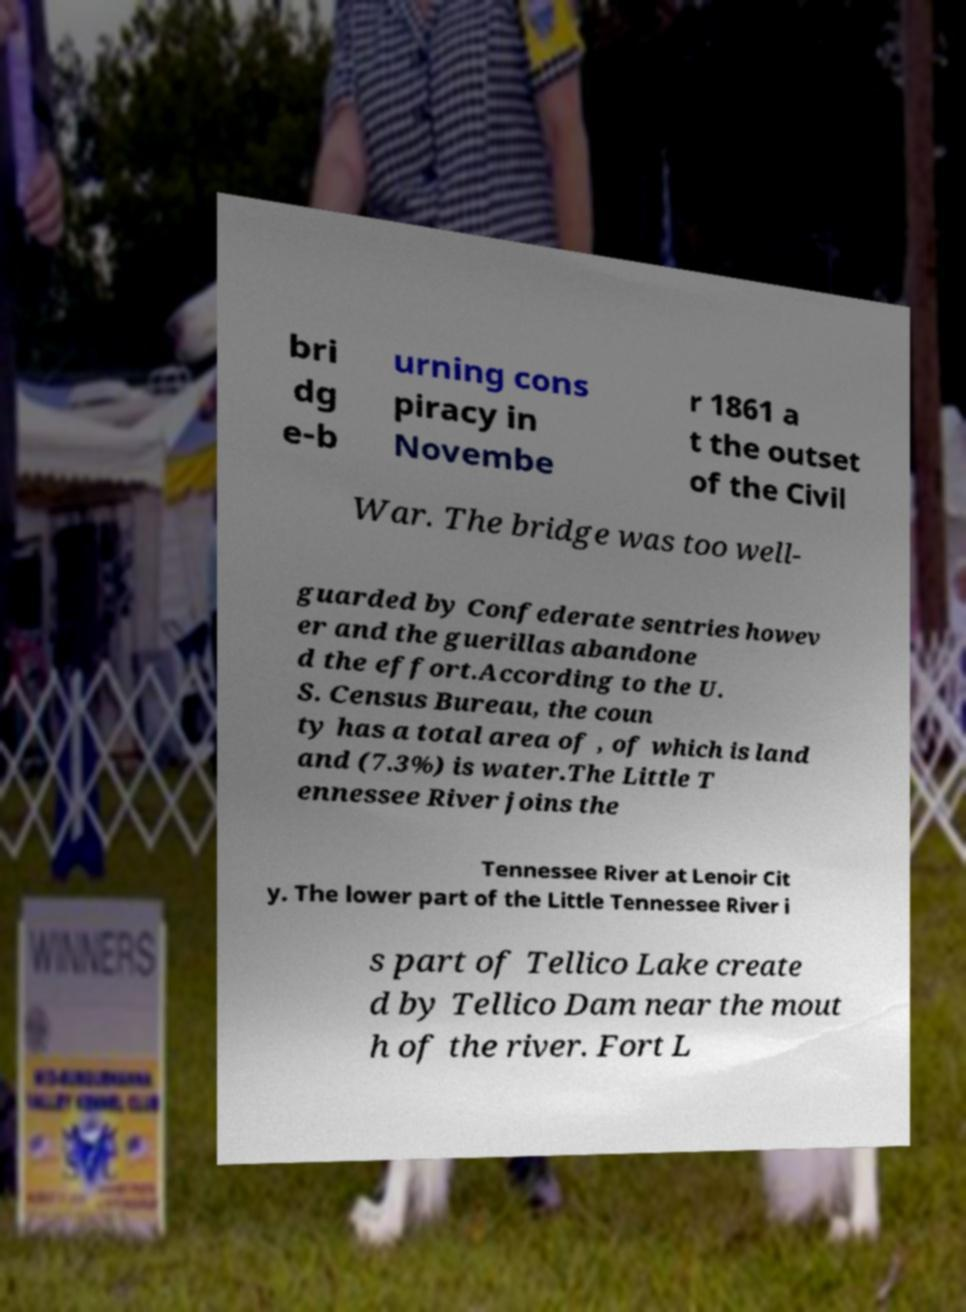Please read and relay the text visible in this image. What does it say? bri dg e-b urning cons piracy in Novembe r 1861 a t the outset of the Civil War. The bridge was too well- guarded by Confederate sentries howev er and the guerillas abandone d the effort.According to the U. S. Census Bureau, the coun ty has a total area of , of which is land and (7.3%) is water.The Little T ennessee River joins the Tennessee River at Lenoir Cit y. The lower part of the Little Tennessee River i s part of Tellico Lake create d by Tellico Dam near the mout h of the river. Fort L 